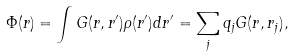Convert formula to latex. <formula><loc_0><loc_0><loc_500><loc_500>\Phi ( r ) = \int G ( r , r ^ { \prime } ) \rho ( r ^ { \prime } ) d r ^ { \prime } = \sum _ { j } q _ { j } G ( r , r _ { j } ) ,</formula> 